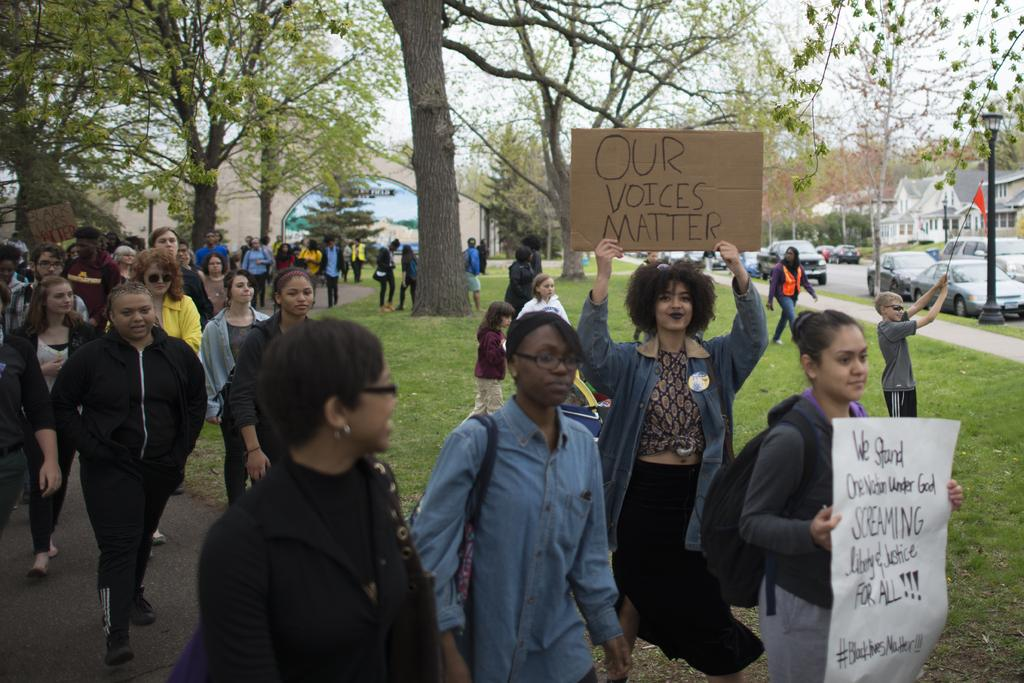What is happening in the middle of the image? There are people in the middle of the image. What are some people doing with the boards they are holding? Some people are holding boards, which might suggest they are participating in a protest or demonstration. What is the movement of the people in the image? Some people are walking. What can be seen in the background of the image? There are trees, grass, buildings, vehicles, a road, street lights, and the sky visible in the background of the image. What type of news is being broadcasted from the tree in the image? There is no tree broadcasting news in the image; the tree is part of the background and not involved in any news-related activity. 